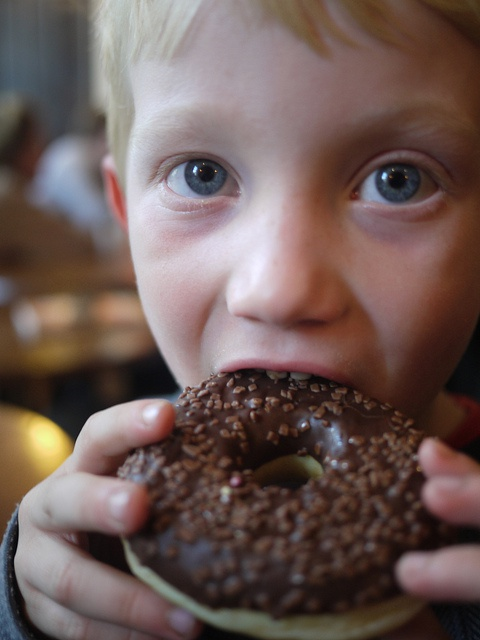Describe the objects in this image and their specific colors. I can see people in gray, darkgray, and maroon tones and donut in gray, black, and maroon tones in this image. 